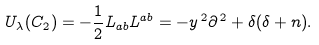<formula> <loc_0><loc_0><loc_500><loc_500>U _ { \lambda } ( C _ { 2 } ) = - \frac { 1 } { 2 } L _ { a b } L ^ { a b } = - y ^ { \, 2 } \partial ^ { \, 2 } + \delta ( \delta + n ) .</formula> 